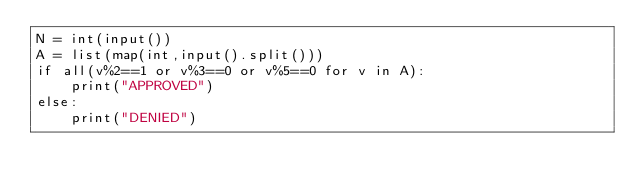<code> <loc_0><loc_0><loc_500><loc_500><_Python_>N = int(input())
A = list(map(int,input().split()))
if all(v%2==1 or v%3==0 or v%5==0 for v in A):
    print("APPROVED")
else:
    print("DENIED")
</code> 